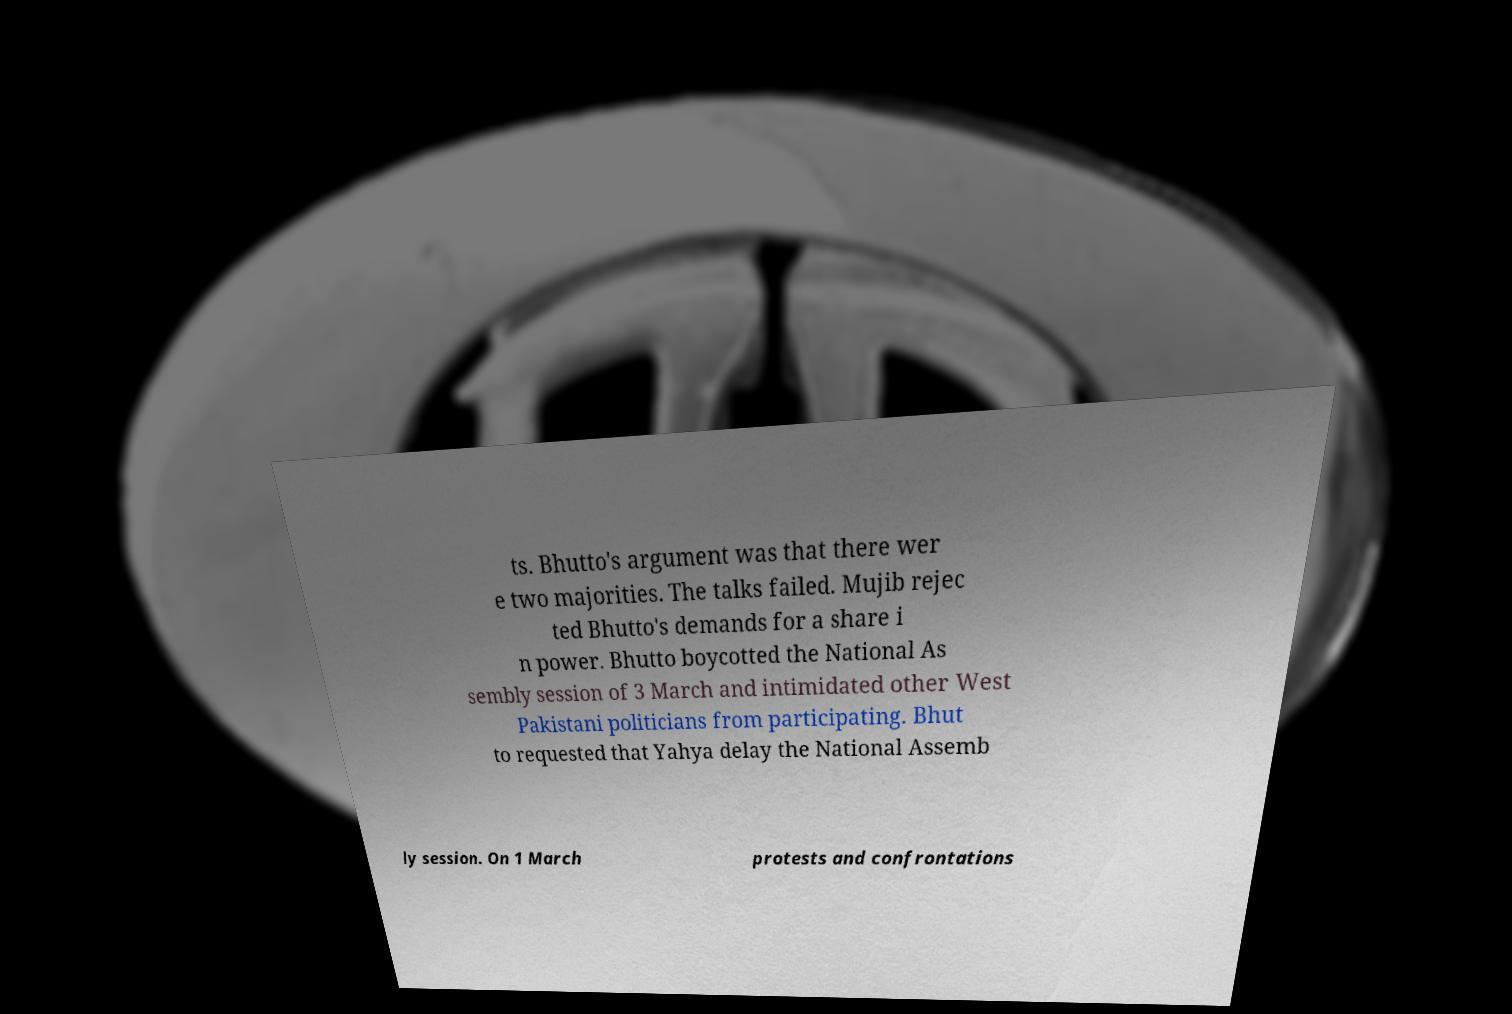Can you read and provide the text displayed in the image?This photo seems to have some interesting text. Can you extract and type it out for me? ts. Bhutto's argument was that there wer e two majorities. The talks failed. Mujib rejec ted Bhutto's demands for a share i n power. Bhutto boycotted the National As sembly session of 3 March and intimidated other West Pakistani politicians from participating. Bhut to requested that Yahya delay the National Assemb ly session. On 1 March protests and confrontations 